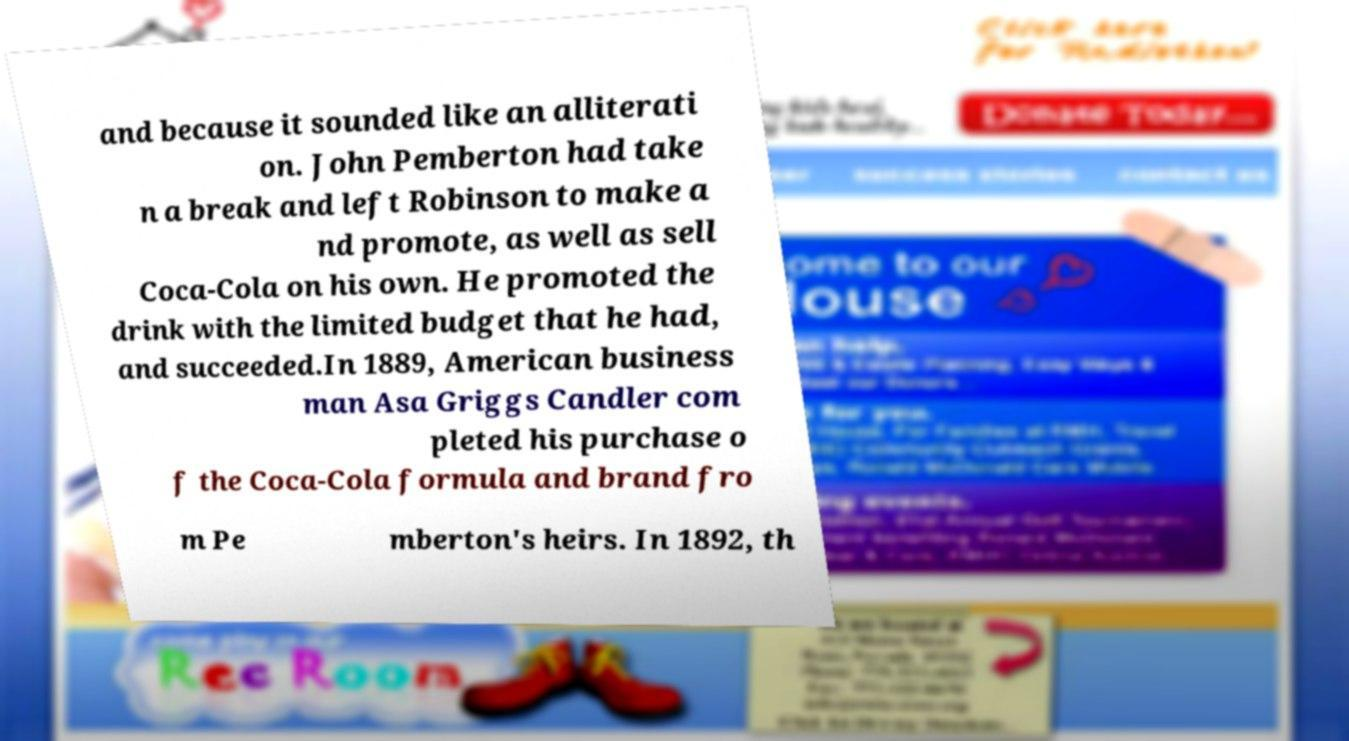Could you assist in decoding the text presented in this image and type it out clearly? and because it sounded like an alliterati on. John Pemberton had take n a break and left Robinson to make a nd promote, as well as sell Coca-Cola on his own. He promoted the drink with the limited budget that he had, and succeeded.In 1889, American business man Asa Griggs Candler com pleted his purchase o f the Coca-Cola formula and brand fro m Pe mberton's heirs. In 1892, th 